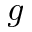<formula> <loc_0><loc_0><loc_500><loc_500>g</formula> 